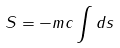<formula> <loc_0><loc_0><loc_500><loc_500>S = - m c \int d s</formula> 